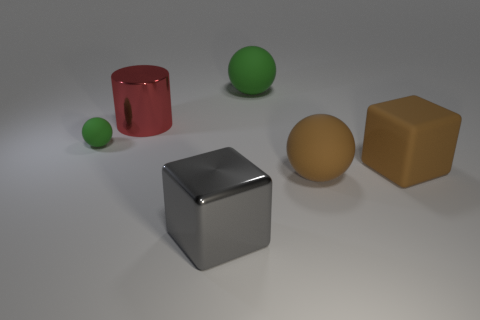Can you describe the texture on the green ball? The green ball appears to have a matte surface with a smooth texture, devoid of any visible patterns or irregularities. 